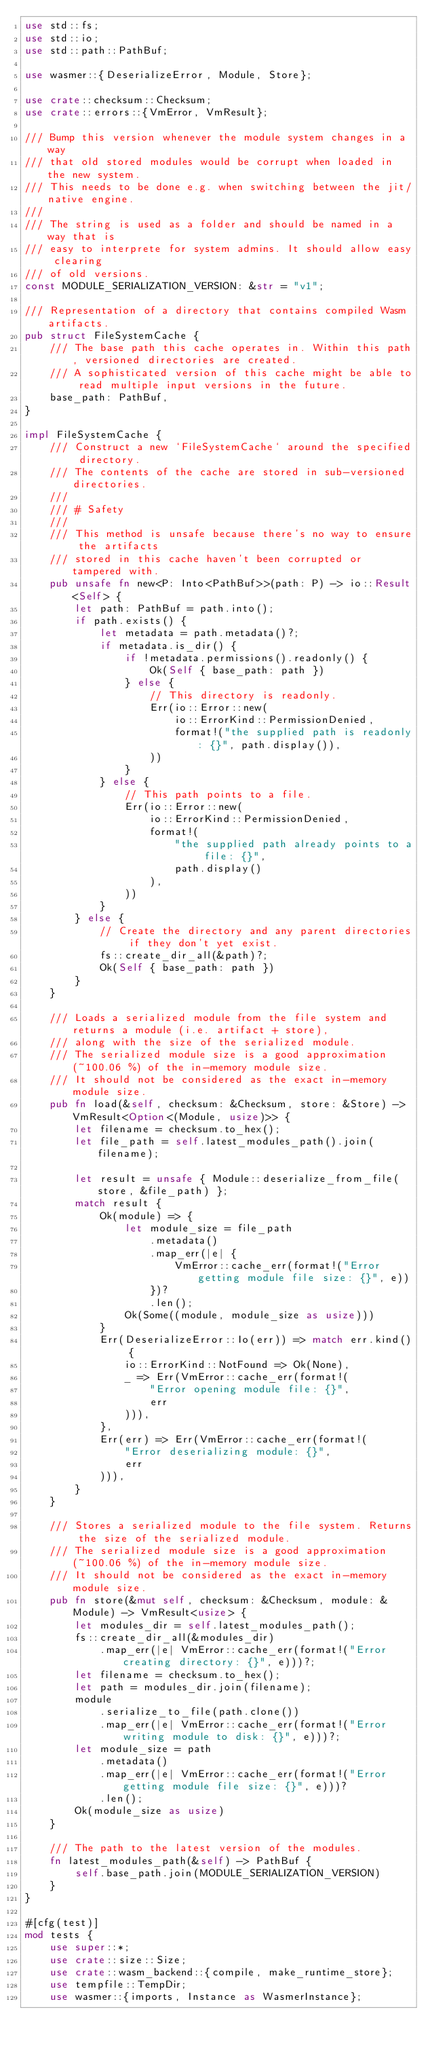Convert code to text. <code><loc_0><loc_0><loc_500><loc_500><_Rust_>use std::fs;
use std::io;
use std::path::PathBuf;

use wasmer::{DeserializeError, Module, Store};

use crate::checksum::Checksum;
use crate::errors::{VmError, VmResult};

/// Bump this version whenever the module system changes in a way
/// that old stored modules would be corrupt when loaded in the new system.
/// This needs to be done e.g. when switching between the jit/native engine.
///
/// The string is used as a folder and should be named in a way that is
/// easy to interprete for system admins. It should allow easy clearing
/// of old versions.
const MODULE_SERIALIZATION_VERSION: &str = "v1";

/// Representation of a directory that contains compiled Wasm artifacts.
pub struct FileSystemCache {
    /// The base path this cache operates in. Within this path, versioned directories are created.
    /// A sophisticated version of this cache might be able to read multiple input versions in the future.
    base_path: PathBuf,
}

impl FileSystemCache {
    /// Construct a new `FileSystemCache` around the specified directory.
    /// The contents of the cache are stored in sub-versioned directories.
    ///
    /// # Safety
    ///
    /// This method is unsafe because there's no way to ensure the artifacts
    /// stored in this cache haven't been corrupted or tampered with.
    pub unsafe fn new<P: Into<PathBuf>>(path: P) -> io::Result<Self> {
        let path: PathBuf = path.into();
        if path.exists() {
            let metadata = path.metadata()?;
            if metadata.is_dir() {
                if !metadata.permissions().readonly() {
                    Ok(Self { base_path: path })
                } else {
                    // This directory is readonly.
                    Err(io::Error::new(
                        io::ErrorKind::PermissionDenied,
                        format!("the supplied path is readonly: {}", path.display()),
                    ))
                }
            } else {
                // This path points to a file.
                Err(io::Error::new(
                    io::ErrorKind::PermissionDenied,
                    format!(
                        "the supplied path already points to a file: {}",
                        path.display()
                    ),
                ))
            }
        } else {
            // Create the directory and any parent directories if they don't yet exist.
            fs::create_dir_all(&path)?;
            Ok(Self { base_path: path })
        }
    }

    /// Loads a serialized module from the file system and returns a module (i.e. artifact + store),
    /// along with the size of the serialized module.
    /// The serialized module size is a good approximation (~100.06 %) of the in-memory module size.
    /// It should not be considered as the exact in-memory module size.
    pub fn load(&self, checksum: &Checksum, store: &Store) -> VmResult<Option<(Module, usize)>> {
        let filename = checksum.to_hex();
        let file_path = self.latest_modules_path().join(filename);

        let result = unsafe { Module::deserialize_from_file(store, &file_path) };
        match result {
            Ok(module) => {
                let module_size = file_path
                    .metadata()
                    .map_err(|e| {
                        VmError::cache_err(format!("Error getting module file size: {}", e))
                    })?
                    .len();
                Ok(Some((module, module_size as usize)))
            }
            Err(DeserializeError::Io(err)) => match err.kind() {
                io::ErrorKind::NotFound => Ok(None),
                _ => Err(VmError::cache_err(format!(
                    "Error opening module file: {}",
                    err
                ))),
            },
            Err(err) => Err(VmError::cache_err(format!(
                "Error deserializing module: {}",
                err
            ))),
        }
    }

    /// Stores a serialized module to the file system. Returns the size of the serialized module.
    /// The serialized module size is a good approximation (~100.06 %) of the in-memory module size.
    /// It should not be considered as the exact in-memory module size.
    pub fn store(&mut self, checksum: &Checksum, module: &Module) -> VmResult<usize> {
        let modules_dir = self.latest_modules_path();
        fs::create_dir_all(&modules_dir)
            .map_err(|e| VmError::cache_err(format!("Error creating directory: {}", e)))?;
        let filename = checksum.to_hex();
        let path = modules_dir.join(filename);
        module
            .serialize_to_file(path.clone())
            .map_err(|e| VmError::cache_err(format!("Error writing module to disk: {}", e)))?;
        let module_size = path
            .metadata()
            .map_err(|e| VmError::cache_err(format!("Error getting module file size: {}", e)))?
            .len();
        Ok(module_size as usize)
    }

    /// The path to the latest version of the modules.
    fn latest_modules_path(&self) -> PathBuf {
        self.base_path.join(MODULE_SERIALIZATION_VERSION)
    }
}

#[cfg(test)]
mod tests {
    use super::*;
    use crate::size::Size;
    use crate::wasm_backend::{compile, make_runtime_store};
    use tempfile::TempDir;
    use wasmer::{imports, Instance as WasmerInstance};</code> 